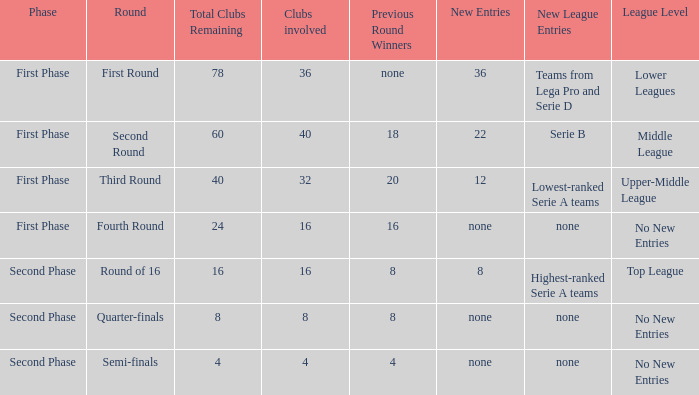In the opening segment, which involves 16 clubs, can you identify the winning teams from the preceding round? 16.0. 